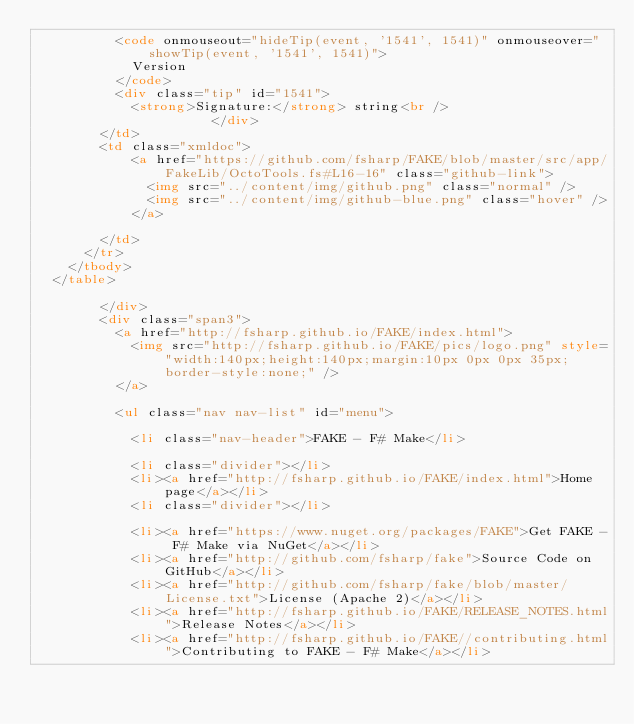Convert code to text. <code><loc_0><loc_0><loc_500><loc_500><_HTML_>          <code onmouseout="hideTip(event, '1541', 1541)" onmouseover="showTip(event, '1541', 1541)">
            Version
          </code>
          <div class="tip" id="1541">
            <strong>Signature:</strong> string<br />
                      </div>
        </td>
        <td class="xmldoc">
            <a href="https://github.com/fsharp/FAKE/blob/master/src/app/FakeLib/OctoTools.fs#L16-16" class="github-link">
              <img src="../content/img/github.png" class="normal" />
              <img src="../content/img/github-blue.png" class="hover" />
            </a>
          
        </td>
      </tr>
    </tbody>
  </table>

        </div>
        <div class="span3">
          <a href="http://fsharp.github.io/FAKE/index.html">
            <img src="http://fsharp.github.io/FAKE/pics/logo.png" style="width:140px;height:140px;margin:10px 0px 0px 35px;border-style:none;" />
          </a>

          <ul class="nav nav-list" id="menu">

            <li class="nav-header">FAKE - F# Make</li>

            <li class="divider"></li>
            <li><a href="http://fsharp.github.io/FAKE/index.html">Home page</a></li>
            <li class="divider"></li>

            <li><a href="https://www.nuget.org/packages/FAKE">Get FAKE - F# Make via NuGet</a></li>
            <li><a href="http://github.com/fsharp/fake">Source Code on GitHub</a></li>
            <li><a href="http://github.com/fsharp/fake/blob/master/License.txt">License (Apache 2)</a></li>
            <li><a href="http://fsharp.github.io/FAKE/RELEASE_NOTES.html">Release Notes</a></li>
            <li><a href="http://fsharp.github.io/FAKE//contributing.html">Contributing to FAKE - F# Make</a></li></code> 